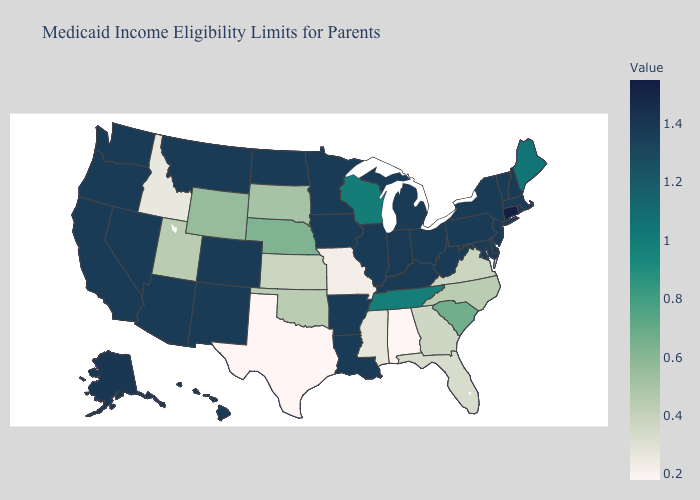Which states have the lowest value in the USA?
Be succinct. Alabama, Texas. Among the states that border Illinois , which have the highest value?
Quick response, please. Indiana. Is the legend a continuous bar?
Quick response, please. Yes. Does Alabama have the lowest value in the USA?
Be succinct. Yes. 